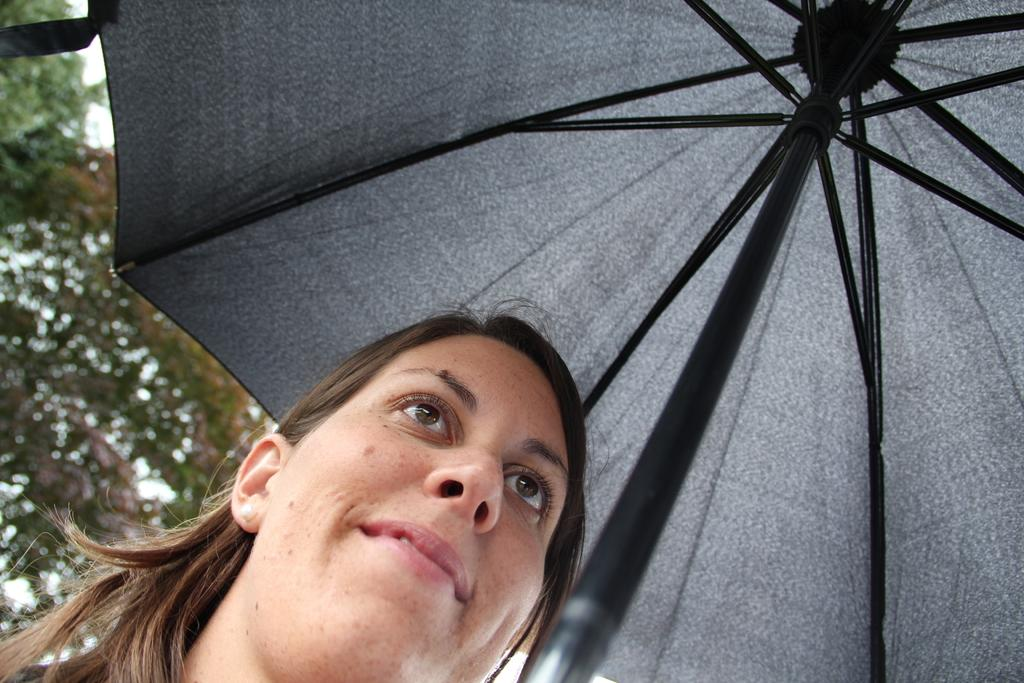Who is present in the image? There is a woman in the image. What is the woman holding in the image? The woman is holding an umbrella. What is the woman's facial expression in the image? The woman is smiling. What can be seen in the background of the image? There is a tree in the background of the image. What type of worm can be seen crawling on the woman's stocking in the image? There is no worm or stocking present in the image, and therefore no such activity can be observed. 